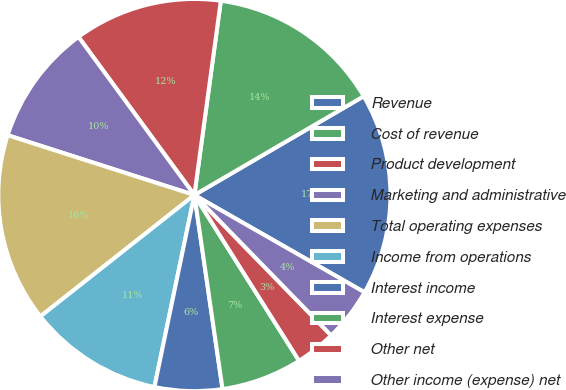<chart> <loc_0><loc_0><loc_500><loc_500><pie_chart><fcel>Revenue<fcel>Cost of revenue<fcel>Product development<fcel>Marketing and administrative<fcel>Total operating expenses<fcel>Income from operations<fcel>Interest income<fcel>Interest expense<fcel>Other net<fcel>Other income (expense) net<nl><fcel>16.67%<fcel>14.44%<fcel>12.22%<fcel>10.0%<fcel>15.56%<fcel>11.11%<fcel>5.56%<fcel>6.67%<fcel>3.33%<fcel>4.44%<nl></chart> 